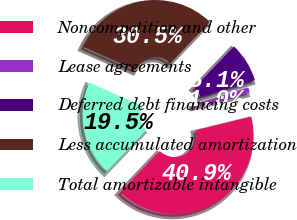Convert chart. <chart><loc_0><loc_0><loc_500><loc_500><pie_chart><fcel>Noncompetition and other<fcel>Lease agreements<fcel>Deferred debt financing costs<fcel>Less accumulated amortization<fcel>Total amortizable intangible<nl><fcel>40.94%<fcel>0.99%<fcel>8.07%<fcel>30.51%<fcel>19.49%<nl></chart> 